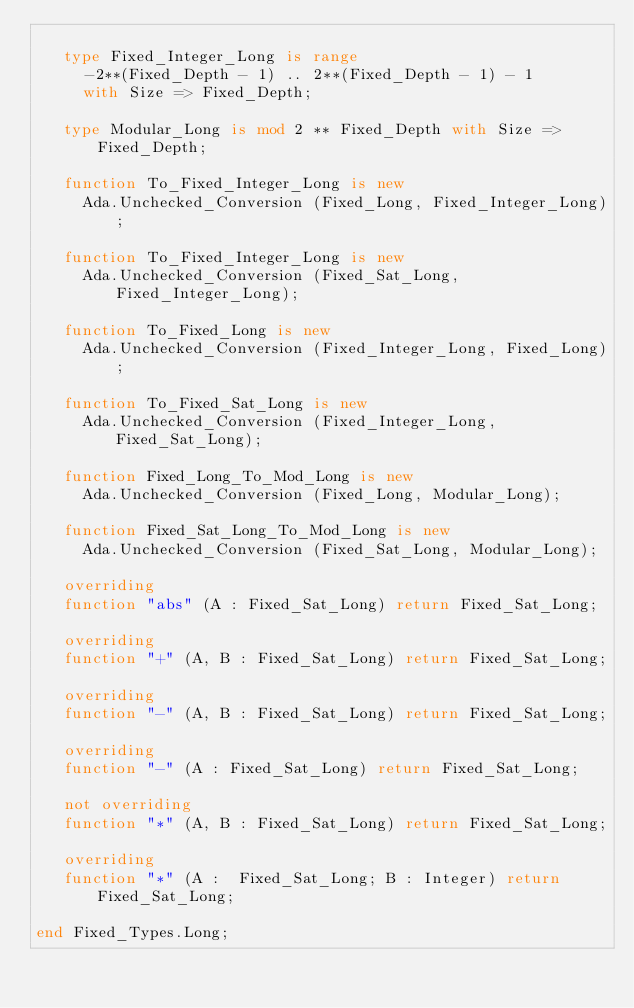<code> <loc_0><loc_0><loc_500><loc_500><_Ada_>
   type Fixed_Integer_Long is range
     -2**(Fixed_Depth - 1) .. 2**(Fixed_Depth - 1) - 1
     with Size => Fixed_Depth;

   type Modular_Long is mod 2 ** Fixed_Depth with Size => Fixed_Depth;

   function To_Fixed_Integer_Long is new
     Ada.Unchecked_Conversion (Fixed_Long, Fixed_Integer_Long);

   function To_Fixed_Integer_Long is new
     Ada.Unchecked_Conversion (Fixed_Sat_Long, Fixed_Integer_Long);

   function To_Fixed_Long is new
     Ada.Unchecked_Conversion (Fixed_Integer_Long, Fixed_Long);

   function To_Fixed_Sat_Long is new
     Ada.Unchecked_Conversion (Fixed_Integer_Long, Fixed_Sat_Long);

   function Fixed_Long_To_Mod_Long is new
     Ada.Unchecked_Conversion (Fixed_Long, Modular_Long);

   function Fixed_Sat_Long_To_Mod_Long is new
     Ada.Unchecked_Conversion (Fixed_Sat_Long, Modular_Long);

   overriding
   function "abs" (A : Fixed_Sat_Long) return Fixed_Sat_Long;

   overriding
   function "+" (A, B : Fixed_Sat_Long) return Fixed_Sat_Long;

   overriding
   function "-" (A, B : Fixed_Sat_Long) return Fixed_Sat_Long;

   overriding
   function "-" (A : Fixed_Sat_Long) return Fixed_Sat_Long;

   not overriding
   function "*" (A, B : Fixed_Sat_Long) return Fixed_Sat_Long;

   overriding
   function "*" (A :  Fixed_Sat_Long; B : Integer) return Fixed_Sat_Long;

end Fixed_Types.Long;

</code> 